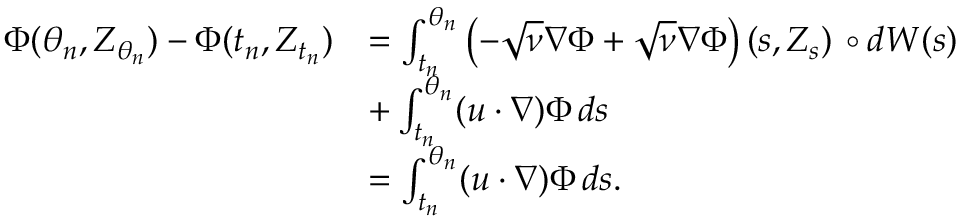<formula> <loc_0><loc_0><loc_500><loc_500>\begin{array} { r l } { \Phi ( \theta _ { n } , Z _ { \theta _ { n } } ) - \Phi ( t _ { n } , Z _ { t _ { n } } ) } & { = \int _ { t _ { n } } ^ { \theta _ { n } } \left ( - \sqrt { \nu } \nabla \Phi + \sqrt { \nu } \nabla \Phi \right ) ( s , Z _ { s } ) \, \circ d W ( s ) } \\ & { + \int _ { t _ { n } } ^ { \theta _ { n } } ( u \cdot \nabla ) \Phi \, d s } \\ & { = \int _ { t _ { n } } ^ { \theta _ { n } } ( u \cdot \nabla ) \Phi \, d s . } \end{array}</formula> 